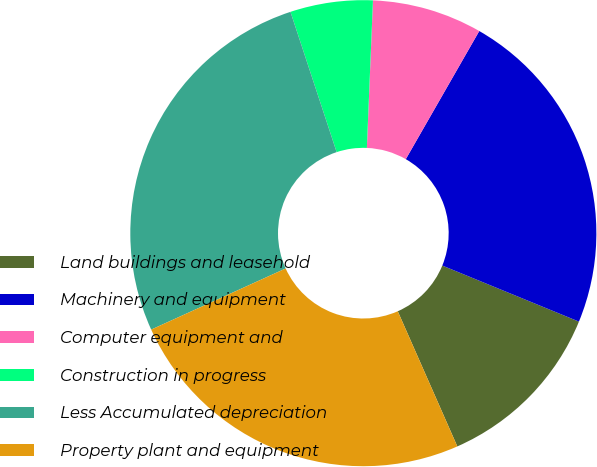<chart> <loc_0><loc_0><loc_500><loc_500><pie_chart><fcel>Land buildings and leasehold<fcel>Machinery and equipment<fcel>Computer equipment and<fcel>Construction in progress<fcel>Less Accumulated depreciation<fcel>Property plant and equipment<nl><fcel>12.2%<fcel>22.91%<fcel>7.63%<fcel>5.72%<fcel>26.73%<fcel>24.82%<nl></chart> 